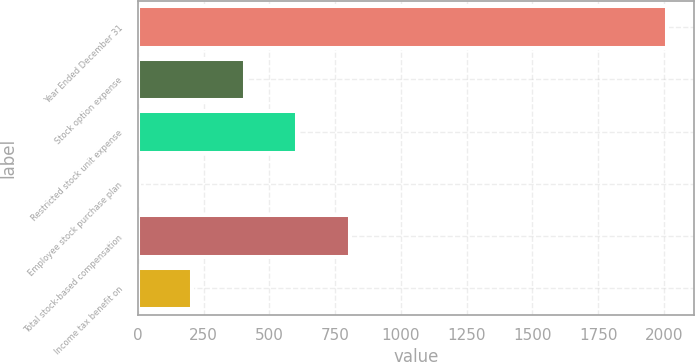<chart> <loc_0><loc_0><loc_500><loc_500><bar_chart><fcel>Year Ended December 31<fcel>Stock option expense<fcel>Restricted stock unit expense<fcel>Employee stock purchase plan<fcel>Total stock-based compensation<fcel>Income tax benefit on<nl><fcel>2013<fcel>405.8<fcel>606.7<fcel>4<fcel>807.6<fcel>204.9<nl></chart> 